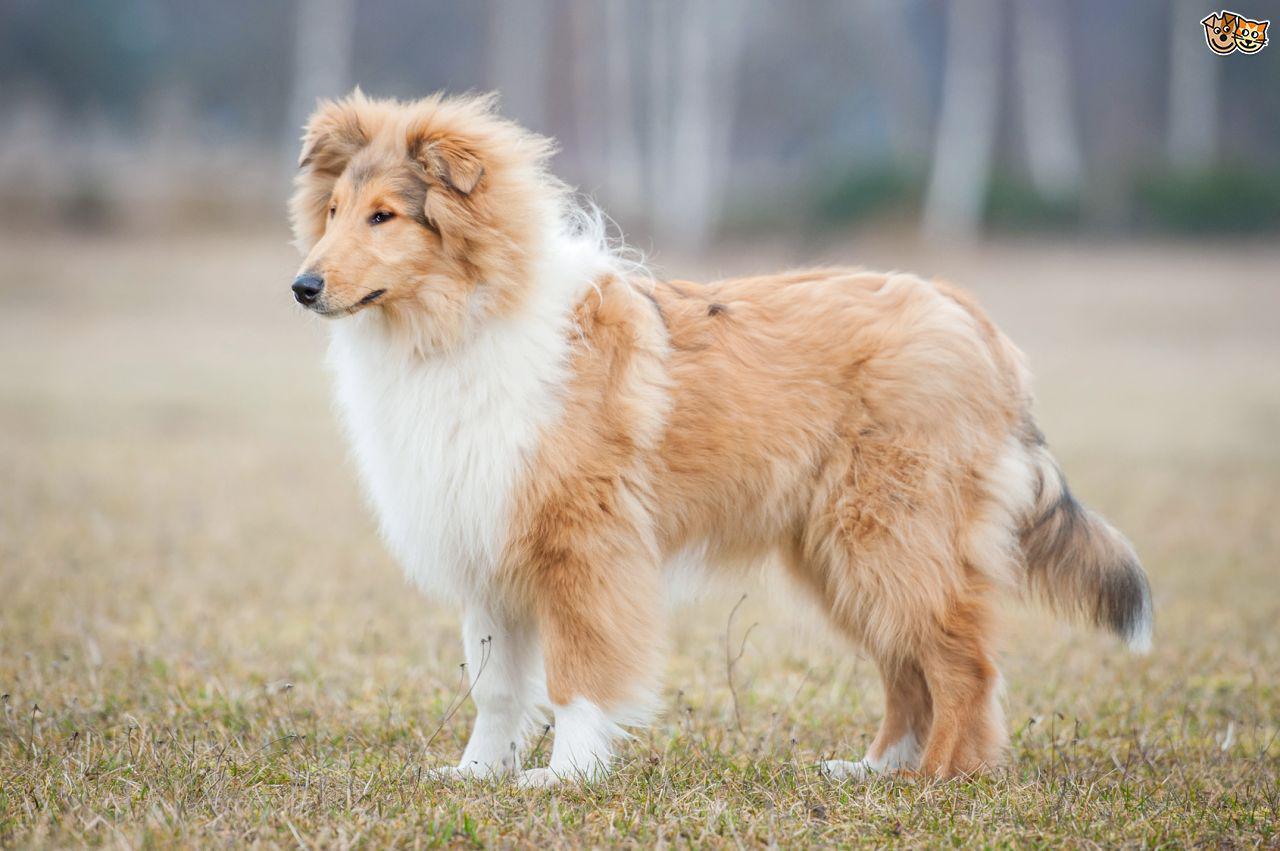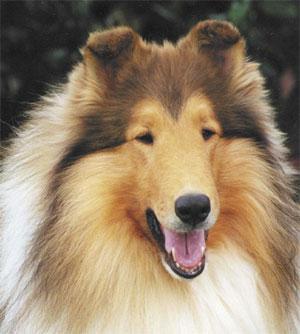The first image is the image on the left, the second image is the image on the right. Examine the images to the left and right. Is the description "One fluffy dog is standing in the grass near flowers." accurate? Answer yes or no. No. 